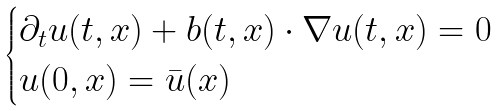<formula> <loc_0><loc_0><loc_500><loc_500>\begin{cases} \partial _ { t } u ( t , x ) + b ( t , x ) \cdot \nabla u ( t , x ) = 0 \\ u ( 0 , x ) = \bar { u } ( x ) \end{cases}</formula> 